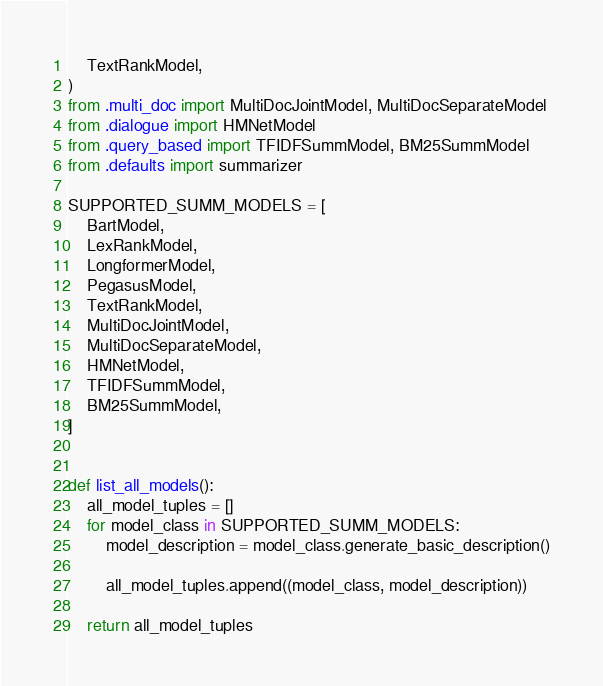Convert code to text. <code><loc_0><loc_0><loc_500><loc_500><_Python_>    TextRankModel,
)
from .multi_doc import MultiDocJointModel, MultiDocSeparateModel
from .dialogue import HMNetModel
from .query_based import TFIDFSummModel, BM25SummModel
from .defaults import summarizer

SUPPORTED_SUMM_MODELS = [
    BartModel,
    LexRankModel,
    LongformerModel,
    PegasusModel,
    TextRankModel,
    MultiDocJointModel,
    MultiDocSeparateModel,
    HMNetModel,
    TFIDFSummModel,
    BM25SummModel,
]


def list_all_models():
    all_model_tuples = []
    for model_class in SUPPORTED_SUMM_MODELS:
        model_description = model_class.generate_basic_description()

        all_model_tuples.append((model_class, model_description))

    return all_model_tuples
</code> 